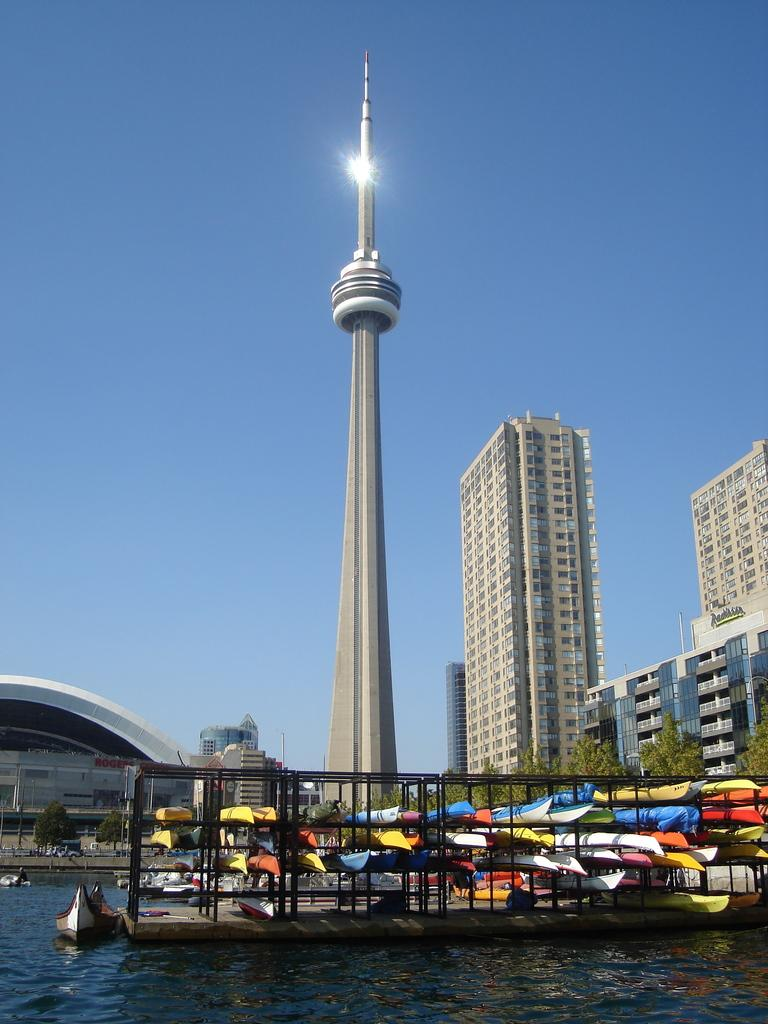What type of structures can be seen in the image? There are buildings in the image. What other natural elements are present in the image? There are trees in the image. What specific feature stands out among the buildings? There is a tower in the image. What type of water-based transportation can be seen in the image? There are boats on the water in the image. What part of the natural environment is visible in the background of the image? The sky is visible in the background of the image. How does the middle of the tower pull the loss of balance in the image? There is no mention of a loss of balance or any action involving the tower in the image. The tower simply stands as a feature among the buildings. 